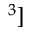Convert formula to latex. <formula><loc_0><loc_0><loc_500><loc_500>^ { 3 } ]</formula> 